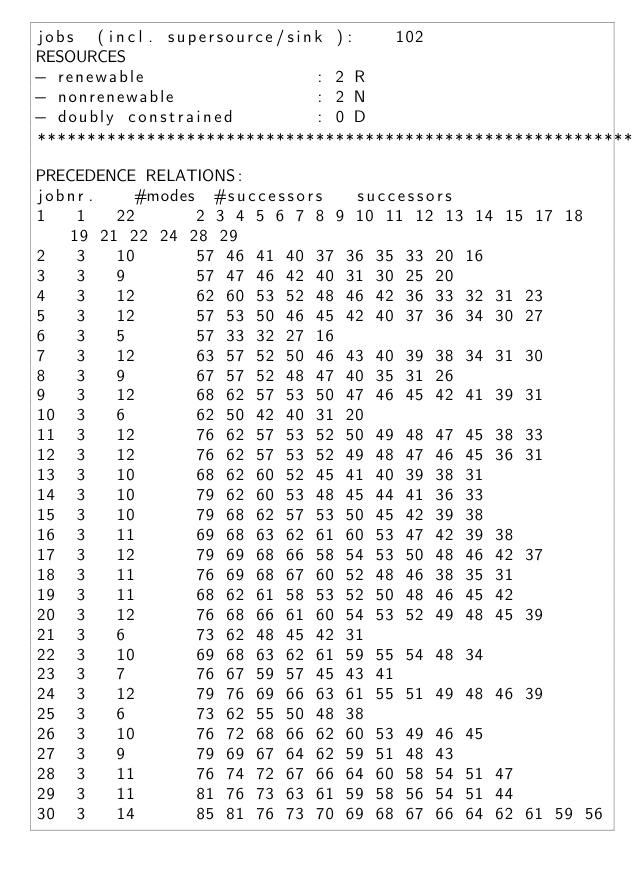<code> <loc_0><loc_0><loc_500><loc_500><_ObjectiveC_>jobs  (incl. supersource/sink ):	102
RESOURCES
- renewable                 : 2 R
- nonrenewable              : 2 N
- doubly constrained        : 0 D
************************************************************************
PRECEDENCE RELATIONS:
jobnr.    #modes  #successors   successors
1	1	22		2 3 4 5 6 7 8 9 10 11 12 13 14 15 17 18 19 21 22 24 28 29 
2	3	10		57 46 41 40 37 36 35 33 20 16 
3	3	9		57 47 46 42 40 31 30 25 20 
4	3	12		62 60 53 52 48 46 42 36 33 32 31 23 
5	3	12		57 53 50 46 45 42 40 37 36 34 30 27 
6	3	5		57 33 32 27 16 
7	3	12		63 57 52 50 46 43 40 39 38 34 31 30 
8	3	9		67 57 52 48 47 40 35 31 26 
9	3	12		68 62 57 53 50 47 46 45 42 41 39 31 
10	3	6		62 50 42 40 31 20 
11	3	12		76 62 57 53 52 50 49 48 47 45 38 33 
12	3	12		76 62 57 53 52 49 48 47 46 45 36 31 
13	3	10		68 62 60 52 45 41 40 39 38 31 
14	3	10		79 62 60 53 48 45 44 41 36 33 
15	3	10		79 68 62 57 53 50 45 42 39 38 
16	3	11		69 68 63 62 61 60 53 47 42 39 38 
17	3	12		79 69 68 66 58 54 53 50 48 46 42 37 
18	3	11		76 69 68 67 60 52 48 46 38 35 31 
19	3	11		68 62 61 58 53 52 50 48 46 45 42 
20	3	12		76 68 66 61 60 54 53 52 49 48 45 39 
21	3	6		73 62 48 45 42 31 
22	3	10		69 68 63 62 61 59 55 54 48 34 
23	3	7		76 67 59 57 45 43 41 
24	3	12		79 76 69 66 63 61 55 51 49 48 46 39 
25	3	6		73 62 55 50 48 38 
26	3	10		76 72 68 66 62 60 53 49 46 45 
27	3	9		79 69 67 64 62 59 51 48 43 
28	3	11		76 74 72 67 66 64 60 58 54 51 47 
29	3	11		81 76 73 63 61 59 58 56 54 51 44 
30	3	14		85 81 76 73 70 69 68 67 66 64 62 61 59 56 </code> 